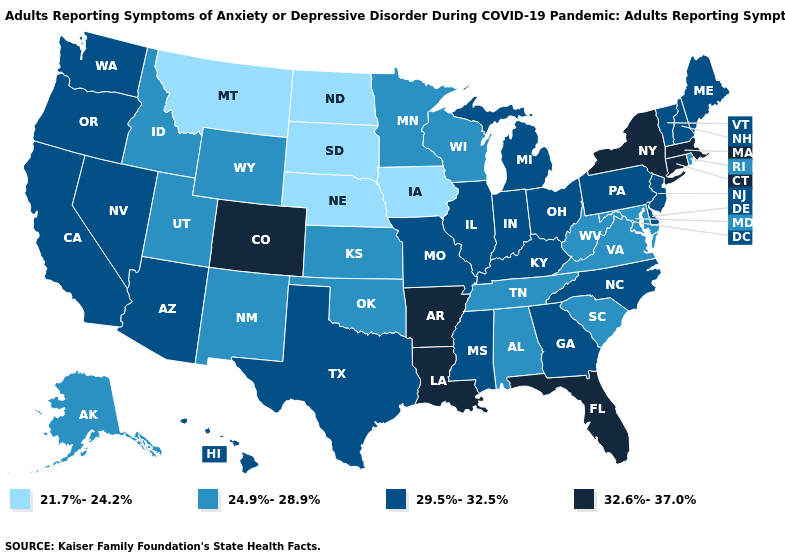Name the states that have a value in the range 24.9%-28.9%?
Keep it brief. Alabama, Alaska, Idaho, Kansas, Maryland, Minnesota, New Mexico, Oklahoma, Rhode Island, South Carolina, Tennessee, Utah, Virginia, West Virginia, Wisconsin, Wyoming. What is the lowest value in the USA?
Quick response, please. 21.7%-24.2%. What is the value of Wyoming?
Concise answer only. 24.9%-28.9%. Name the states that have a value in the range 21.7%-24.2%?
Short answer required. Iowa, Montana, Nebraska, North Dakota, South Dakota. What is the value of Connecticut?
Concise answer only. 32.6%-37.0%. Among the states that border Arizona , does Colorado have the highest value?
Short answer required. Yes. What is the value of Oklahoma?
Quick response, please. 24.9%-28.9%. Name the states that have a value in the range 21.7%-24.2%?
Give a very brief answer. Iowa, Montana, Nebraska, North Dakota, South Dakota. What is the value of Mississippi?
Be succinct. 29.5%-32.5%. What is the value of Nevada?
Be succinct. 29.5%-32.5%. What is the lowest value in the USA?
Short answer required. 21.7%-24.2%. Name the states that have a value in the range 32.6%-37.0%?
Short answer required. Arkansas, Colorado, Connecticut, Florida, Louisiana, Massachusetts, New York. What is the value of Nevada?
Answer briefly. 29.5%-32.5%. Does Iowa have the lowest value in the USA?
Answer briefly. Yes. 